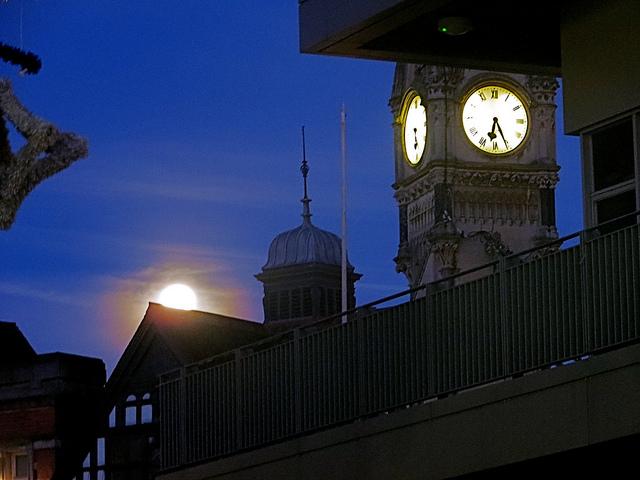What is the shape on the inside of the clock?
Be succinct. Circle. Are there any street lights near the clock?
Concise answer only. No. Does the moon form a triangle with the other circles?
Keep it brief. No. Is it dark outside?
Quick response, please. Yes. What time is it?
Be succinct. 6:25. Is it early morning?
Give a very brief answer. No. What time of day is this?
Quick response, please. Night. Is it daytime?
Concise answer only. No. What time does the clock show?
Give a very brief answer. 6:25. What time does the clock say?
Answer briefly. 6:25. Is the sun setting?
Quick response, please. Yes. What type of scene is this?
Concise answer only. Night. 